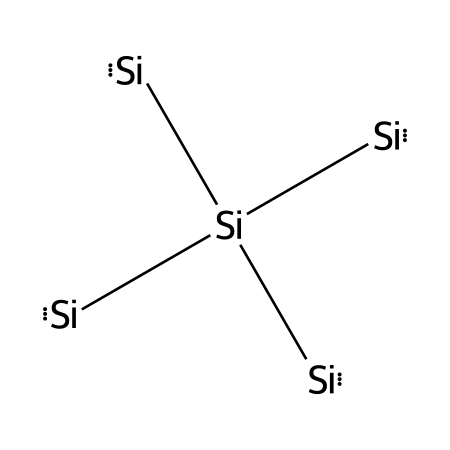What element is primarily represented in this structure? The SMILES representation shows only silicon atoms arranged in a tetrahedral configuration, characteristic of crystalline silicon.
Answer: silicon How many silicon atoms are present in the structure? By analyzing the SMILES notation, we count five silicon atoms indicated by [Si].
Answer: five What type of bonding is likely present in the crystal structure of silicon? The silicon atoms are bonded together in a tetrahedral shape, indicating covalent bonding typical of silicon's structure.
Answer: covalent What is the common crystal structure form of silicon used in computer chips? The typical crystal structure of silicon used in electronics is the diamond cubic lattice, which allows for efficient electronic properties.
Answer: diamond cubic Why is silicon preferred for use in computer chips? Silicon is favored due to its semiconductor properties, which enable effective control of electrical conductivity essential for chip functionality.
Answer: semiconductor What is the spatial arrangement of the silicon atoms in the crystal lattice? The silicon atoms are arranged tetrahedrally, with each silicon atom bonded to four neighboring silicon atoms in a 3D network.
Answer: tetrahedral How does the crystal structure of silicon affect its electrical properties? The tetrahedral structure of silicon allows it to have a band gap, which is crucial for its semiconductor behavior, enabling switching in electronic devices.
Answer: band gap 